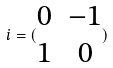<formula> <loc_0><loc_0><loc_500><loc_500>i = ( \begin{matrix} 0 & - 1 \\ 1 & 0 \end{matrix} )</formula> 